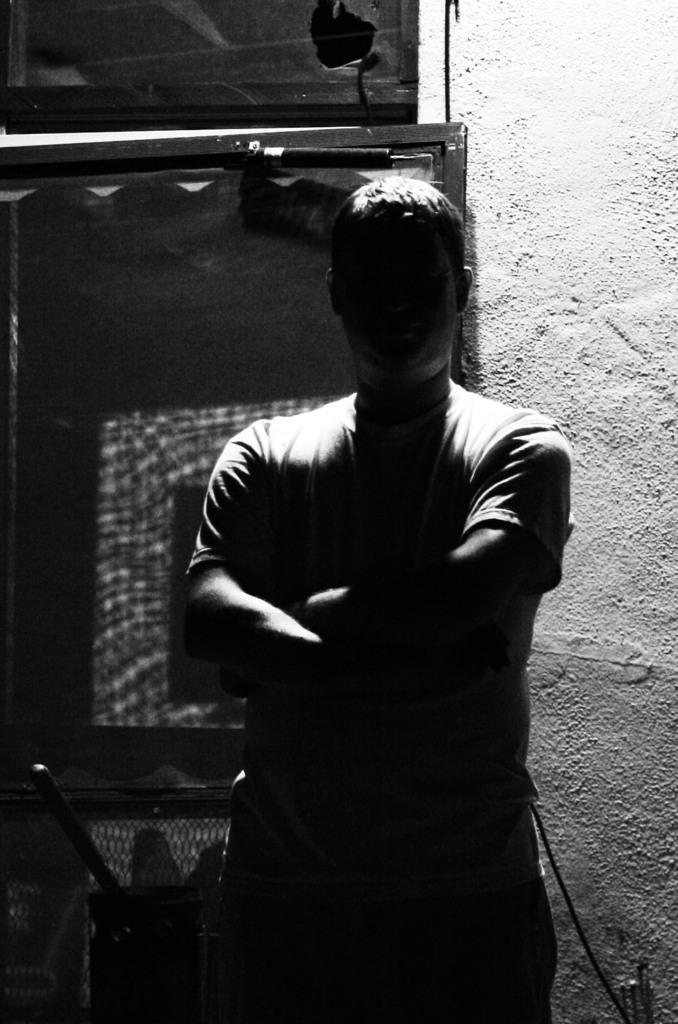What is the main subject of the image? There is a man standing in the image. What can be seen in the background of the image? There is a wall in the background of the image. Are there any other objects visible in the background? Yes, there are some objects visible in the background of the image. What type of scent can be detected from the man in the image? There is no information about the scent of the man in the image, so it cannot be determined. 